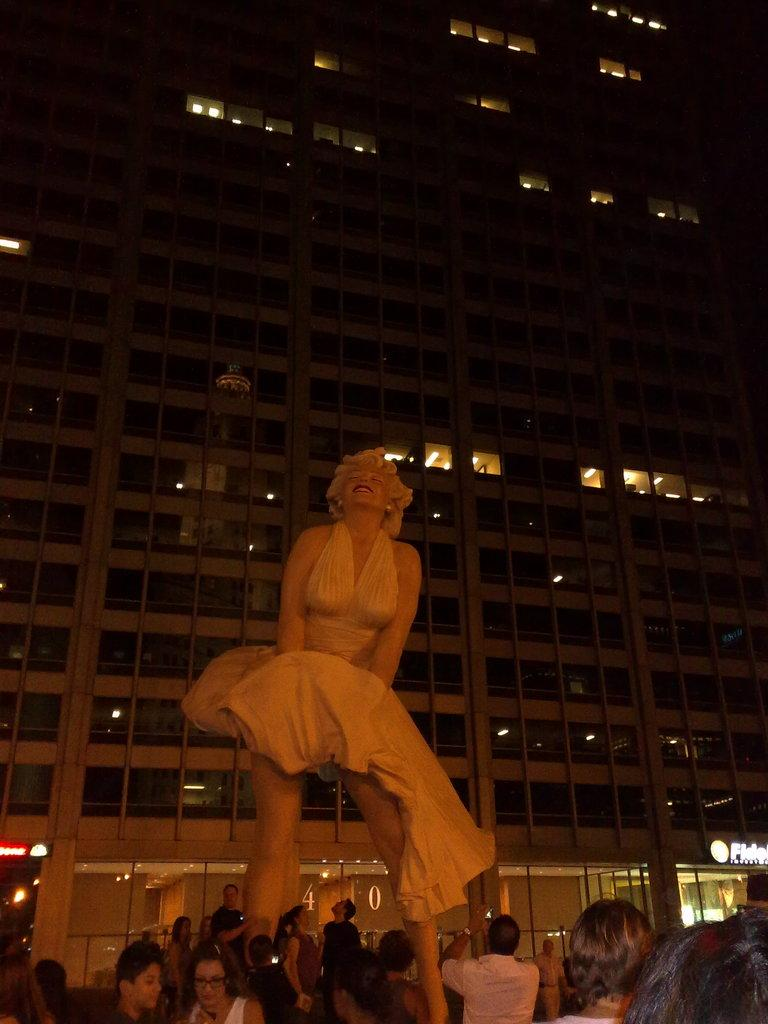Who is the main subject in the image? There is a lady in the image. Are there any other people in the image? Yes, there are people around the lady. What can be seen in the background of the image? There is a building in the background of the image. What type of cloth is draped over the library in the image? There is no library or cloth present in the image. 